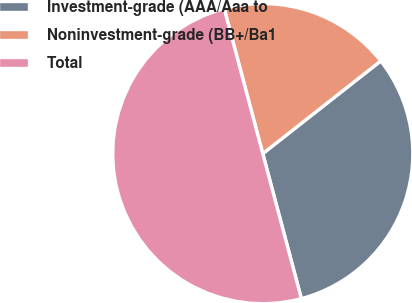<chart> <loc_0><loc_0><loc_500><loc_500><pie_chart><fcel>Investment-grade (AAA/Aaa to<fcel>Noninvestment-grade (BB+/Ba1<fcel>Total<nl><fcel>31.46%<fcel>18.54%<fcel>50.0%<nl></chart> 